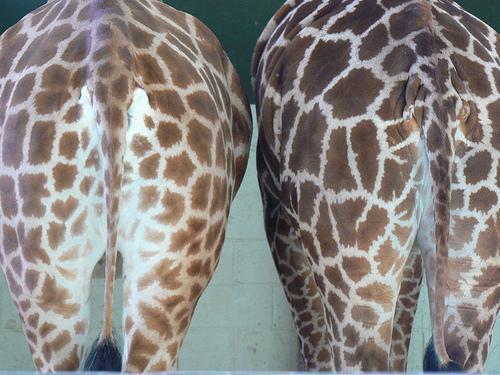How many giraffes are pictured?
Give a very brief answer. 2. 